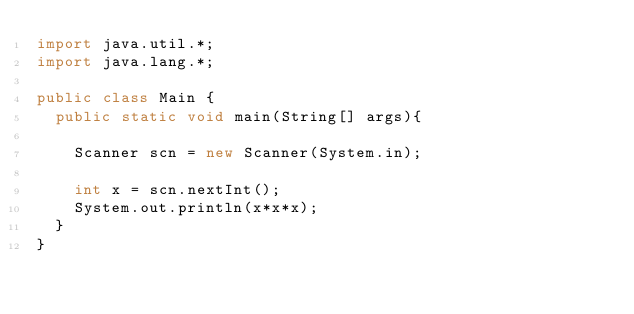Convert code to text. <code><loc_0><loc_0><loc_500><loc_500><_Java_>import java.util.*;
import java.lang.*;

public class Main {
	public static void main(String[] args){

		Scanner scn = new Scanner(System.in);
		
		int x = scn.nextInt();
		System.out.println(x*x*x);
	}
}</code> 